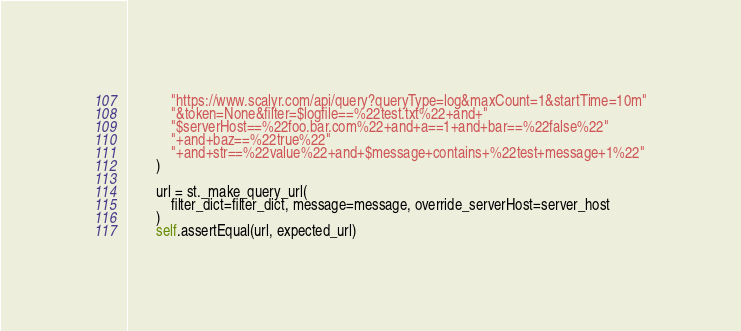Convert code to text. <code><loc_0><loc_0><loc_500><loc_500><_Python_>            "https://www.scalyr.com/api/query?queryType=log&maxCount=1&startTime=10m"
            "&token=None&filter=$logfile==%22test.txt%22+and+"
            "$serverHost==%22foo.bar.com%22+and+a==1+and+bar==%22false%22"
            "+and+baz==%22true%22"
            "+and+str==%22value%22+and+$message+contains+%22test+message+1%22"
        )

        url = st._make_query_url(
            filter_dict=filter_dict, message=message, override_serverHost=server_host
        )
        self.assertEqual(url, expected_url)
</code> 